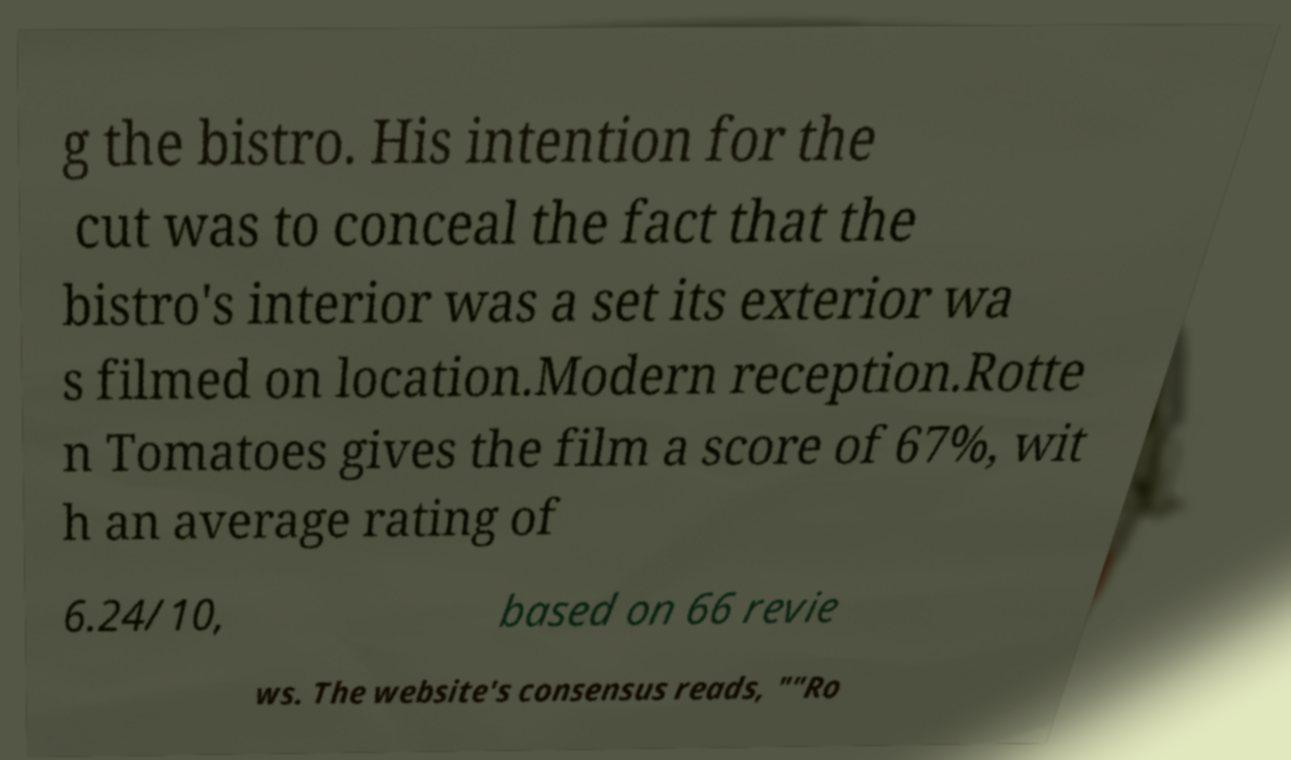Can you read and provide the text displayed in the image?This photo seems to have some interesting text. Can you extract and type it out for me? g the bistro. His intention for the cut was to conceal the fact that the bistro's interior was a set its exterior wa s filmed on location.Modern reception.Rotte n Tomatoes gives the film a score of 67%, wit h an average rating of 6.24/10, based on 66 revie ws. The website's consensus reads, ""Ro 